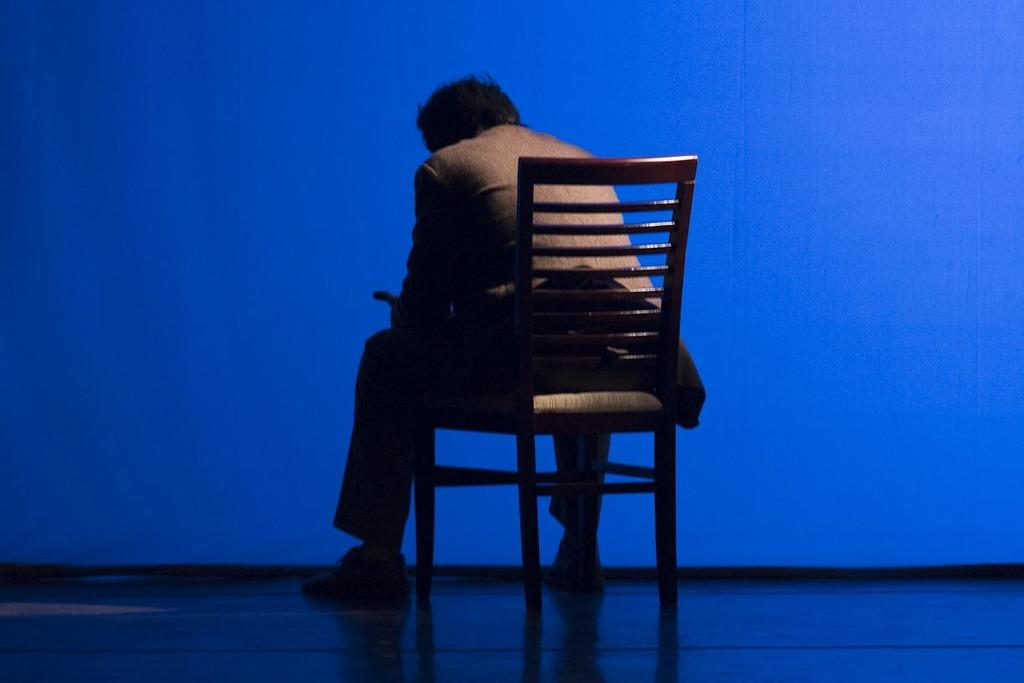What color is the background of the image? The background of the image is blue. What is the man in the image doing? The man is sitting on a chair in the image. What is located at the bottom portion of the image? There is a platform at the bottom portion of the image. How many people are in the crowd surrounding the man in the image? There is no crowd present in the image; it only features a man sitting on a chair and a blue background. 